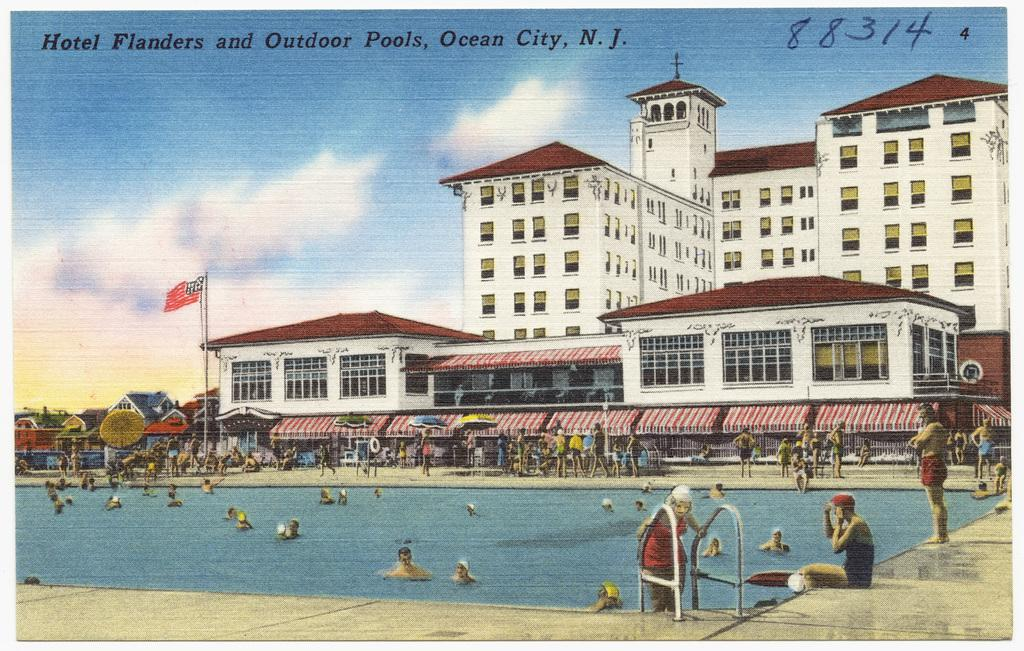What is the main subject of the image? There is a depiction of a swimming pool in the image. Are there any people present in the image? Yes, there are people in the image. What else can be seen in the image besides the swimming pool and people? There are buildings, a flag, clouds in the sky, and text written in the image. Can you describe the sky in the image? The sky is visible in the image, and there are clouds present. What type of space attack is depicted in the image? There is no space attack present in the image; it features a swimming pool, people, buildings, a flag, clouds, and text. Can you tell me the value of the stamp on the flag in the image? There is no stamp present on the flag in the image. 